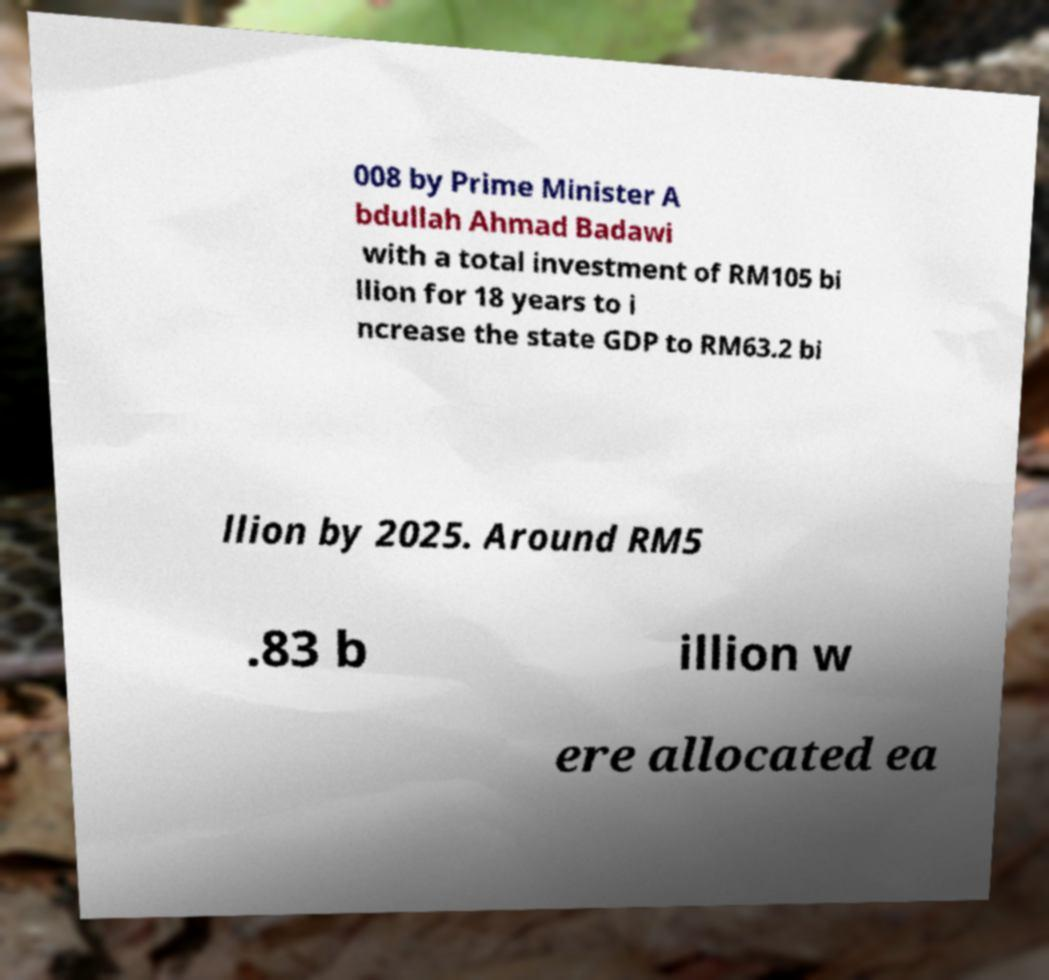Could you extract and type out the text from this image? 008 by Prime Minister A bdullah Ahmad Badawi with a total investment of RM105 bi llion for 18 years to i ncrease the state GDP to RM63.2 bi llion by 2025. Around RM5 .83 b illion w ere allocated ea 